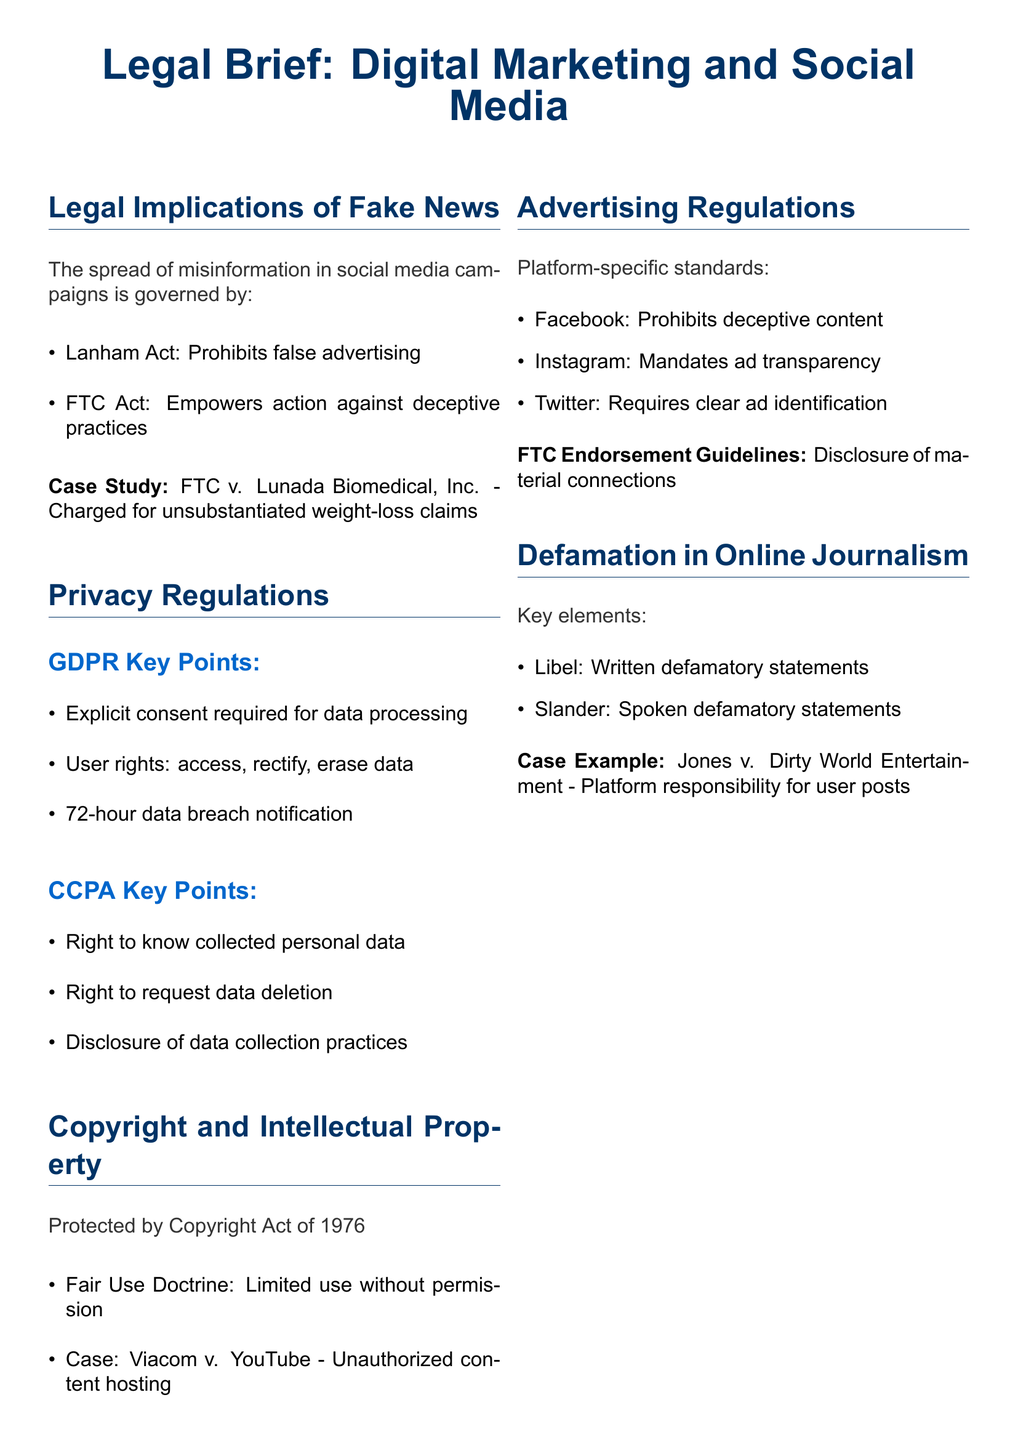What laws govern misinformation in social media campaigns? The document specifies the Lanham Act and the FTC Act as governing laws against misinformation spread during social media marketing campaigns.
Answer: Lanham Act, FTC Act What is required by the GDPR for data processing? According to the document, explicit consent is required for processing any user data under GDPR guidelines.
Answer: Explicit consent What case exemplifies copyright issues in content hosting? The document mentions the Viacom v. YouTube case as an example of legal conflict over unauthorized content hosting.
Answer: Viacom v. YouTube What do Instagram guidelines mandate for advertisements? The document states that Instagram requires transparency in advertising, ensuring that all sponsored content is clearly disclosed.
Answer: Ad transparency What are the two types of defamatory statements outlined in the document? The document identifies libel and slander as the two key types of defamatory statements relevant to online journalism.
Answer: Libel and slander What is the key takeaway regarding information sharing? The document advises that marketers should verify information before sharing it to avoid legal issues stemming from misinformation.
Answer: Verify information What is the time frame for data breach notification under GDPR? It is specified in the document that organizations must notify users of data breaches within 72 hours under GDPR regulations.
Answer: 72 hours What does the CCPA grant users regarding their data? The document outlines that the CCPA gives users the right to know what personal data is collected, which includes requesting data deletion.
Answer: Right to know What guideline must Twitter advertisements follow? The document asserts that ads on Twitter must clearly identify themselves as advertisements, adhering to platform rules on disclosure.
Answer: Clear ad identification 